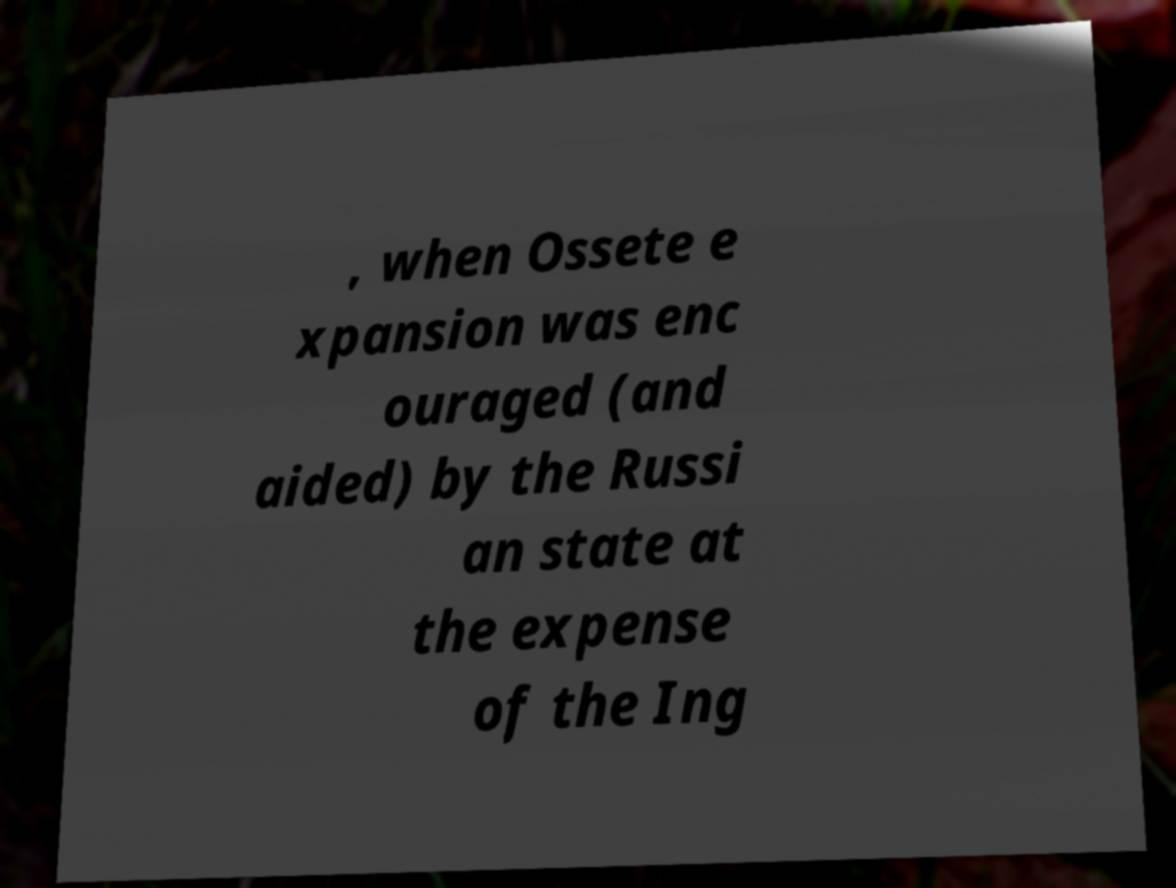What messages or text are displayed in this image? I need them in a readable, typed format. , when Ossete e xpansion was enc ouraged (and aided) by the Russi an state at the expense of the Ing 